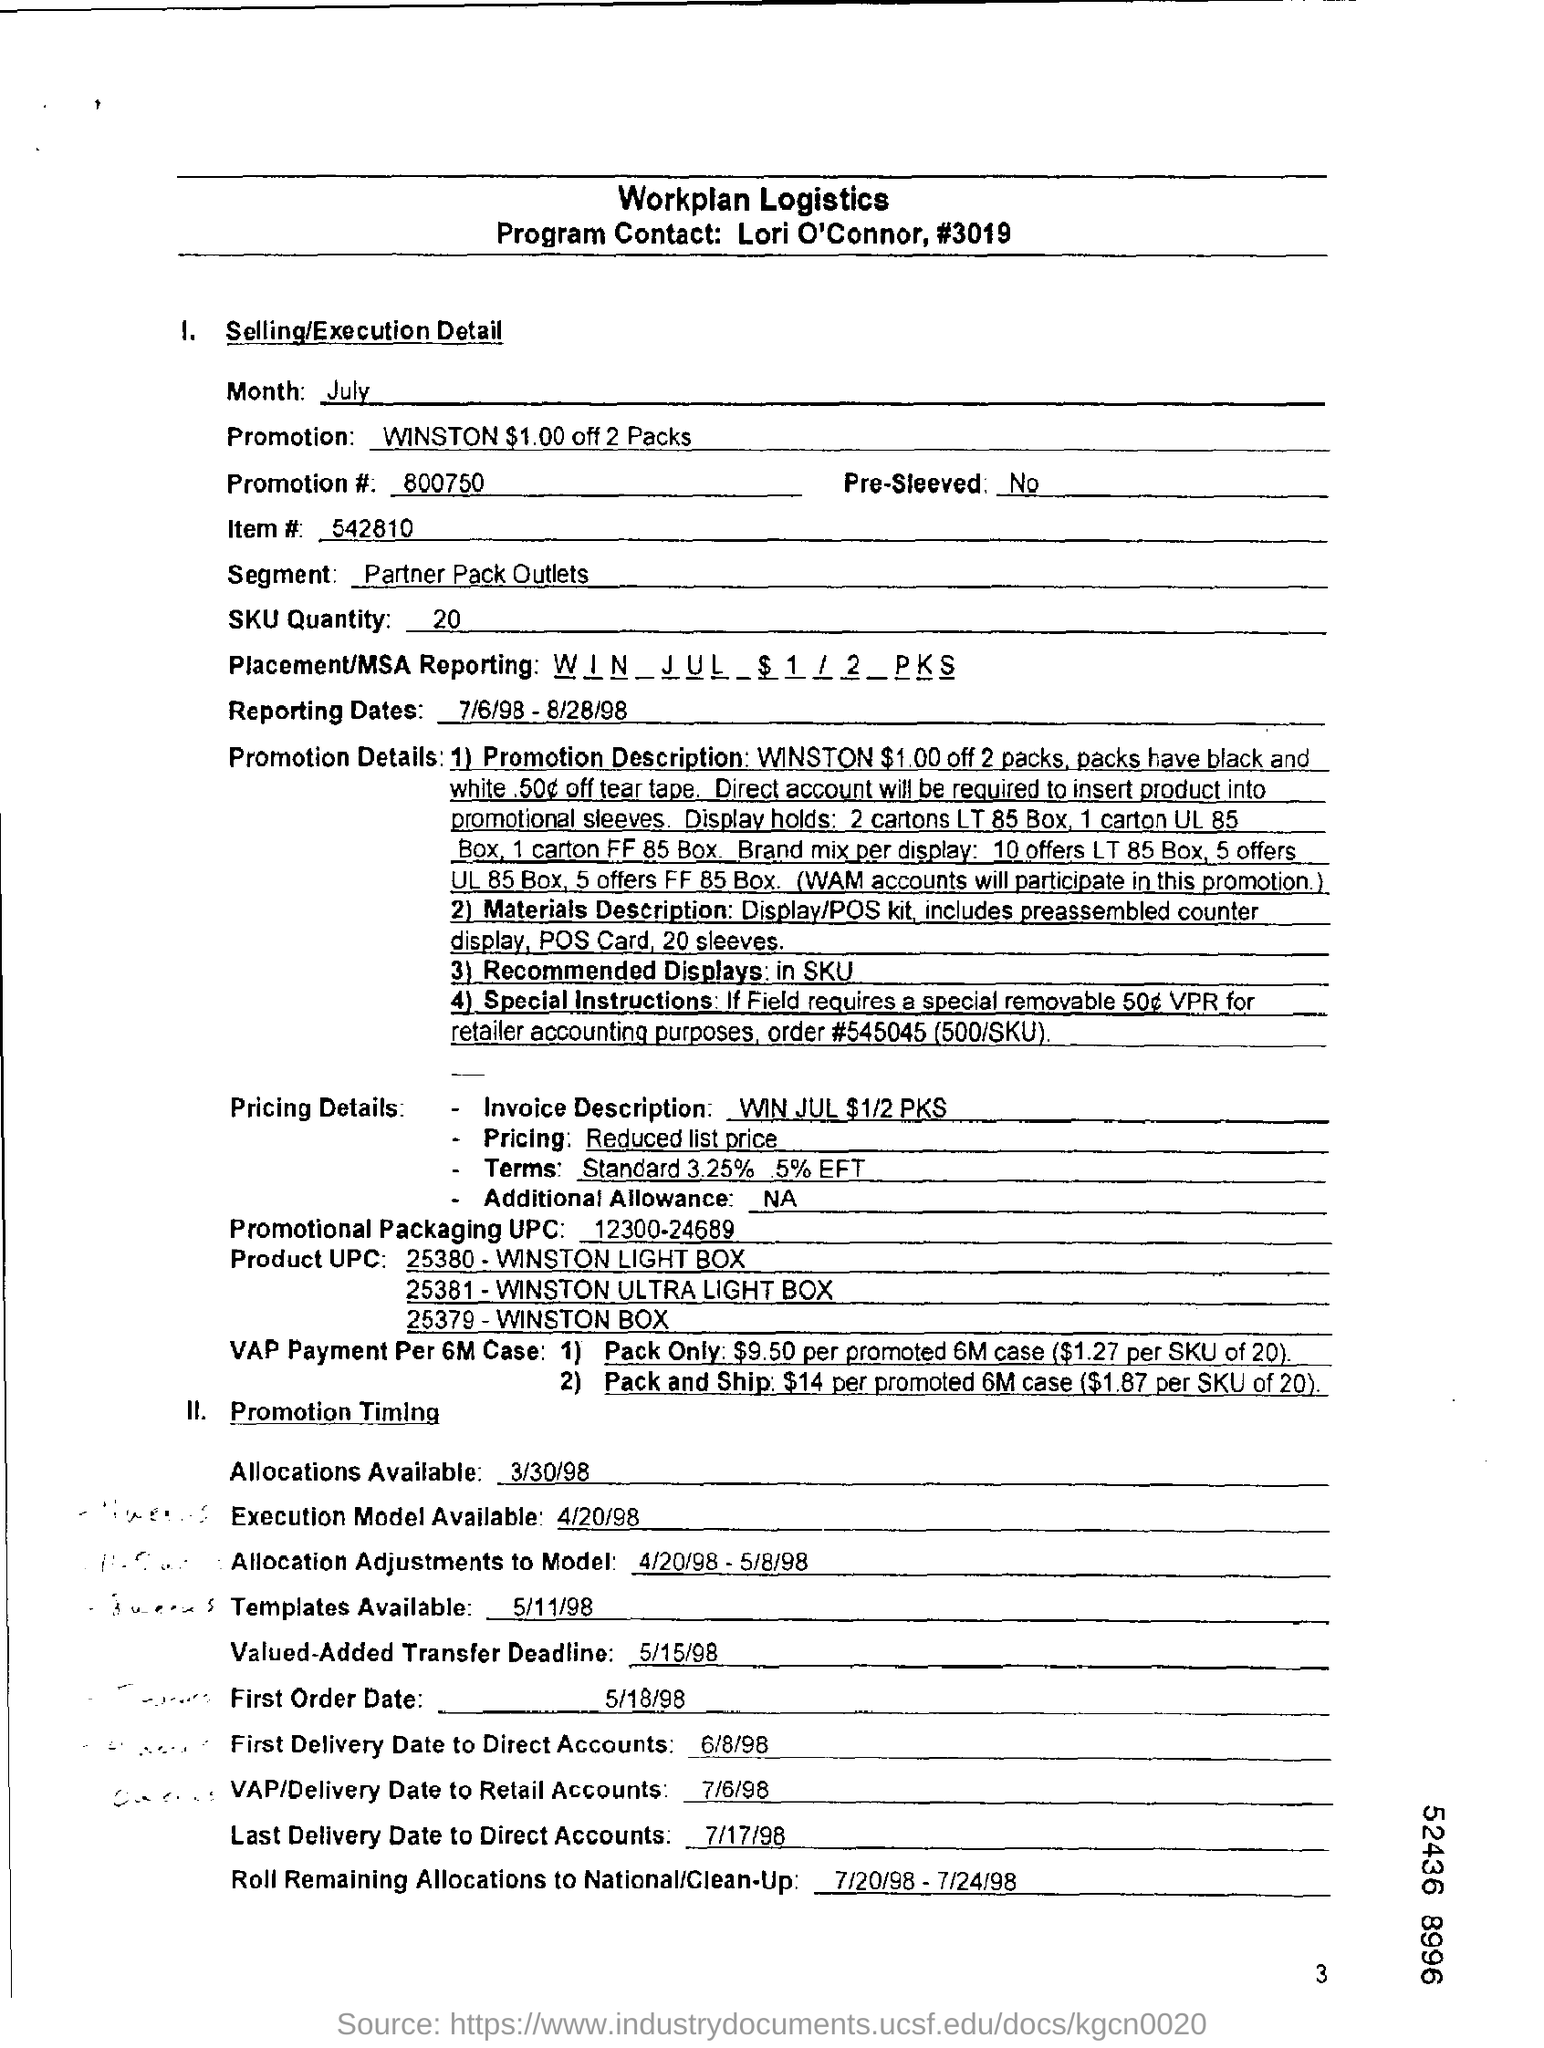Identify some key points in this picture. The item number is 542810. The program contact is Lori O'Connor. The quantity of the SKU is 20... The segment under selling/executive detail is focused on Partner Pack outlets. The garment is not pre-sleeved. 